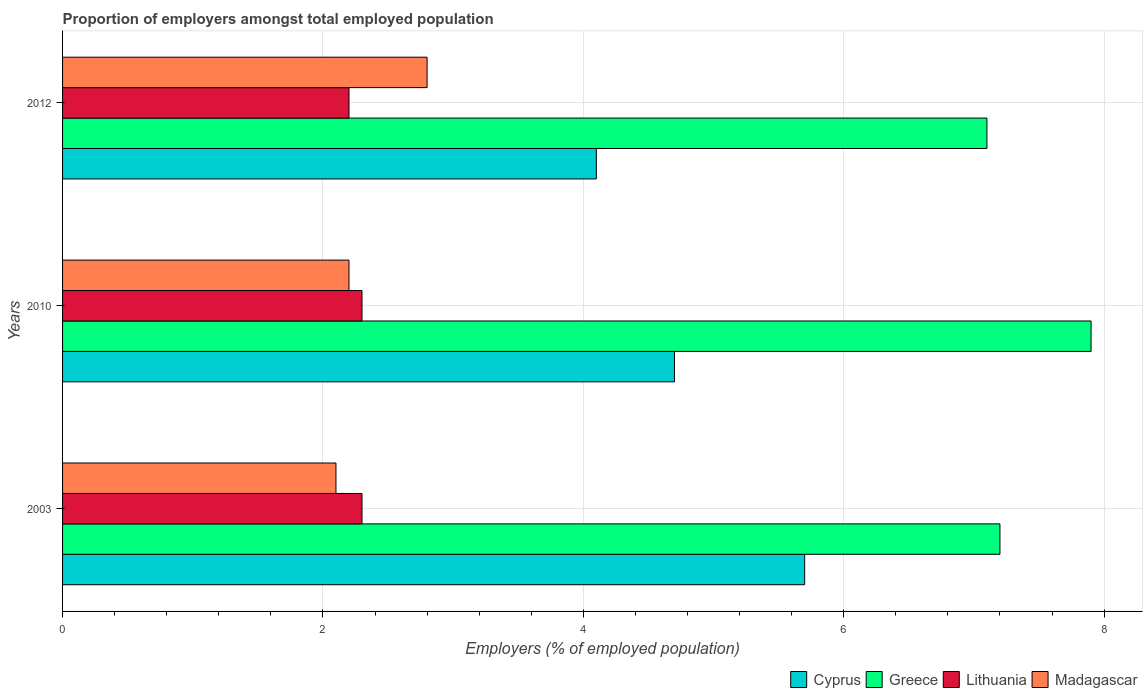Are the number of bars on each tick of the Y-axis equal?
Offer a very short reply. Yes. How many bars are there on the 2nd tick from the bottom?
Your answer should be compact. 4. What is the label of the 3rd group of bars from the top?
Your answer should be very brief. 2003. In how many cases, is the number of bars for a given year not equal to the number of legend labels?
Ensure brevity in your answer.  0. What is the proportion of employers in Madagascar in 2010?
Your response must be concise. 2.2. Across all years, what is the maximum proportion of employers in Greece?
Ensure brevity in your answer.  7.9. Across all years, what is the minimum proportion of employers in Madagascar?
Make the answer very short. 2.1. In which year was the proportion of employers in Madagascar maximum?
Keep it short and to the point. 2012. What is the total proportion of employers in Cyprus in the graph?
Provide a succinct answer. 14.5. What is the average proportion of employers in Greece per year?
Offer a terse response. 7.4. In the year 2003, what is the difference between the proportion of employers in Cyprus and proportion of employers in Madagascar?
Keep it short and to the point. 3.6. What is the ratio of the proportion of employers in Cyprus in 2010 to that in 2012?
Your answer should be compact. 1.15. Is the proportion of employers in Madagascar in 2003 less than that in 2012?
Offer a terse response. Yes. Is the difference between the proportion of employers in Cyprus in 2003 and 2012 greater than the difference between the proportion of employers in Madagascar in 2003 and 2012?
Your response must be concise. Yes. What is the difference between the highest and the second highest proportion of employers in Greece?
Provide a short and direct response. 0.7. What is the difference between the highest and the lowest proportion of employers in Lithuania?
Provide a short and direct response. 0.1. In how many years, is the proportion of employers in Cyprus greater than the average proportion of employers in Cyprus taken over all years?
Your response must be concise. 1. What does the 2nd bar from the top in 2003 represents?
Your answer should be very brief. Lithuania. What does the 2nd bar from the bottom in 2012 represents?
Provide a succinct answer. Greece. Is it the case that in every year, the sum of the proportion of employers in Lithuania and proportion of employers in Madagascar is greater than the proportion of employers in Cyprus?
Offer a terse response. No. How many bars are there?
Provide a short and direct response. 12. How many years are there in the graph?
Keep it short and to the point. 3. What is the difference between two consecutive major ticks on the X-axis?
Make the answer very short. 2. Are the values on the major ticks of X-axis written in scientific E-notation?
Provide a succinct answer. No. Does the graph contain any zero values?
Give a very brief answer. No. Does the graph contain grids?
Make the answer very short. Yes. What is the title of the graph?
Ensure brevity in your answer.  Proportion of employers amongst total employed population. Does "North America" appear as one of the legend labels in the graph?
Your answer should be compact. No. What is the label or title of the X-axis?
Your response must be concise. Employers (% of employed population). What is the label or title of the Y-axis?
Give a very brief answer. Years. What is the Employers (% of employed population) of Cyprus in 2003?
Provide a short and direct response. 5.7. What is the Employers (% of employed population) in Greece in 2003?
Your answer should be compact. 7.2. What is the Employers (% of employed population) of Lithuania in 2003?
Give a very brief answer. 2.3. What is the Employers (% of employed population) in Madagascar in 2003?
Ensure brevity in your answer.  2.1. What is the Employers (% of employed population) in Cyprus in 2010?
Offer a terse response. 4.7. What is the Employers (% of employed population) of Greece in 2010?
Keep it short and to the point. 7.9. What is the Employers (% of employed population) in Lithuania in 2010?
Keep it short and to the point. 2.3. What is the Employers (% of employed population) of Madagascar in 2010?
Offer a very short reply. 2.2. What is the Employers (% of employed population) in Cyprus in 2012?
Make the answer very short. 4.1. What is the Employers (% of employed population) of Greece in 2012?
Offer a very short reply. 7.1. What is the Employers (% of employed population) in Lithuania in 2012?
Keep it short and to the point. 2.2. What is the Employers (% of employed population) of Madagascar in 2012?
Provide a short and direct response. 2.8. Across all years, what is the maximum Employers (% of employed population) of Cyprus?
Offer a very short reply. 5.7. Across all years, what is the maximum Employers (% of employed population) in Greece?
Make the answer very short. 7.9. Across all years, what is the maximum Employers (% of employed population) of Lithuania?
Ensure brevity in your answer.  2.3. Across all years, what is the maximum Employers (% of employed population) of Madagascar?
Provide a succinct answer. 2.8. Across all years, what is the minimum Employers (% of employed population) of Cyprus?
Offer a very short reply. 4.1. Across all years, what is the minimum Employers (% of employed population) in Greece?
Your answer should be very brief. 7.1. Across all years, what is the minimum Employers (% of employed population) of Lithuania?
Your answer should be compact. 2.2. Across all years, what is the minimum Employers (% of employed population) in Madagascar?
Provide a succinct answer. 2.1. What is the total Employers (% of employed population) in Greece in the graph?
Your response must be concise. 22.2. What is the difference between the Employers (% of employed population) of Cyprus in 2003 and that in 2010?
Ensure brevity in your answer.  1. What is the difference between the Employers (% of employed population) of Greece in 2003 and that in 2010?
Your answer should be very brief. -0.7. What is the difference between the Employers (% of employed population) of Lithuania in 2003 and that in 2010?
Give a very brief answer. 0. What is the difference between the Employers (% of employed population) in Madagascar in 2003 and that in 2010?
Offer a terse response. -0.1. What is the difference between the Employers (% of employed population) in Madagascar in 2003 and that in 2012?
Give a very brief answer. -0.7. What is the difference between the Employers (% of employed population) of Cyprus in 2010 and that in 2012?
Your answer should be compact. 0.6. What is the difference between the Employers (% of employed population) in Greece in 2010 and that in 2012?
Give a very brief answer. 0.8. What is the difference between the Employers (% of employed population) in Lithuania in 2010 and that in 2012?
Give a very brief answer. 0.1. What is the difference between the Employers (% of employed population) in Madagascar in 2010 and that in 2012?
Give a very brief answer. -0.6. What is the difference between the Employers (% of employed population) in Cyprus in 2003 and the Employers (% of employed population) in Greece in 2010?
Ensure brevity in your answer.  -2.2. What is the difference between the Employers (% of employed population) in Greece in 2003 and the Employers (% of employed population) in Lithuania in 2010?
Your answer should be very brief. 4.9. What is the difference between the Employers (% of employed population) of Greece in 2003 and the Employers (% of employed population) of Madagascar in 2010?
Provide a succinct answer. 5. What is the difference between the Employers (% of employed population) of Lithuania in 2003 and the Employers (% of employed population) of Madagascar in 2010?
Ensure brevity in your answer.  0.1. What is the difference between the Employers (% of employed population) of Cyprus in 2003 and the Employers (% of employed population) of Greece in 2012?
Give a very brief answer. -1.4. What is the difference between the Employers (% of employed population) of Cyprus in 2003 and the Employers (% of employed population) of Lithuania in 2012?
Offer a very short reply. 3.5. What is the difference between the Employers (% of employed population) of Greece in 2003 and the Employers (% of employed population) of Madagascar in 2012?
Offer a terse response. 4.4. What is the difference between the Employers (% of employed population) in Lithuania in 2003 and the Employers (% of employed population) in Madagascar in 2012?
Provide a succinct answer. -0.5. What is the difference between the Employers (% of employed population) of Cyprus in 2010 and the Employers (% of employed population) of Greece in 2012?
Offer a very short reply. -2.4. What is the difference between the Employers (% of employed population) of Greece in 2010 and the Employers (% of employed population) of Madagascar in 2012?
Ensure brevity in your answer.  5.1. What is the average Employers (% of employed population) in Cyprus per year?
Provide a short and direct response. 4.83. What is the average Employers (% of employed population) in Greece per year?
Your response must be concise. 7.4. What is the average Employers (% of employed population) in Lithuania per year?
Offer a terse response. 2.27. What is the average Employers (% of employed population) of Madagascar per year?
Offer a terse response. 2.37. In the year 2003, what is the difference between the Employers (% of employed population) of Cyprus and Employers (% of employed population) of Madagascar?
Ensure brevity in your answer.  3.6. In the year 2003, what is the difference between the Employers (% of employed population) in Greece and Employers (% of employed population) in Lithuania?
Offer a very short reply. 4.9. In the year 2003, what is the difference between the Employers (% of employed population) in Lithuania and Employers (% of employed population) in Madagascar?
Give a very brief answer. 0.2. In the year 2010, what is the difference between the Employers (% of employed population) in Cyprus and Employers (% of employed population) in Lithuania?
Your answer should be compact. 2.4. In the year 2010, what is the difference between the Employers (% of employed population) of Cyprus and Employers (% of employed population) of Madagascar?
Provide a succinct answer. 2.5. In the year 2010, what is the difference between the Employers (% of employed population) in Greece and Employers (% of employed population) in Lithuania?
Provide a short and direct response. 5.6. In the year 2010, what is the difference between the Employers (% of employed population) in Lithuania and Employers (% of employed population) in Madagascar?
Make the answer very short. 0.1. In the year 2012, what is the difference between the Employers (% of employed population) in Cyprus and Employers (% of employed population) in Lithuania?
Give a very brief answer. 1.9. In the year 2012, what is the difference between the Employers (% of employed population) in Cyprus and Employers (% of employed population) in Madagascar?
Your answer should be very brief. 1.3. In the year 2012, what is the difference between the Employers (% of employed population) in Greece and Employers (% of employed population) in Lithuania?
Your answer should be compact. 4.9. In the year 2012, what is the difference between the Employers (% of employed population) in Greece and Employers (% of employed population) in Madagascar?
Your answer should be very brief. 4.3. What is the ratio of the Employers (% of employed population) in Cyprus in 2003 to that in 2010?
Ensure brevity in your answer.  1.21. What is the ratio of the Employers (% of employed population) of Greece in 2003 to that in 2010?
Ensure brevity in your answer.  0.91. What is the ratio of the Employers (% of employed population) in Madagascar in 2003 to that in 2010?
Ensure brevity in your answer.  0.95. What is the ratio of the Employers (% of employed population) of Cyprus in 2003 to that in 2012?
Your answer should be very brief. 1.39. What is the ratio of the Employers (% of employed population) of Greece in 2003 to that in 2012?
Offer a terse response. 1.01. What is the ratio of the Employers (% of employed population) of Lithuania in 2003 to that in 2012?
Provide a succinct answer. 1.05. What is the ratio of the Employers (% of employed population) of Madagascar in 2003 to that in 2012?
Provide a short and direct response. 0.75. What is the ratio of the Employers (% of employed population) in Cyprus in 2010 to that in 2012?
Give a very brief answer. 1.15. What is the ratio of the Employers (% of employed population) of Greece in 2010 to that in 2012?
Your response must be concise. 1.11. What is the ratio of the Employers (% of employed population) of Lithuania in 2010 to that in 2012?
Your answer should be very brief. 1.05. What is the ratio of the Employers (% of employed population) of Madagascar in 2010 to that in 2012?
Ensure brevity in your answer.  0.79. What is the difference between the highest and the second highest Employers (% of employed population) in Lithuania?
Offer a very short reply. 0. What is the difference between the highest and the second highest Employers (% of employed population) in Madagascar?
Offer a very short reply. 0.6. What is the difference between the highest and the lowest Employers (% of employed population) of Madagascar?
Provide a succinct answer. 0.7. 